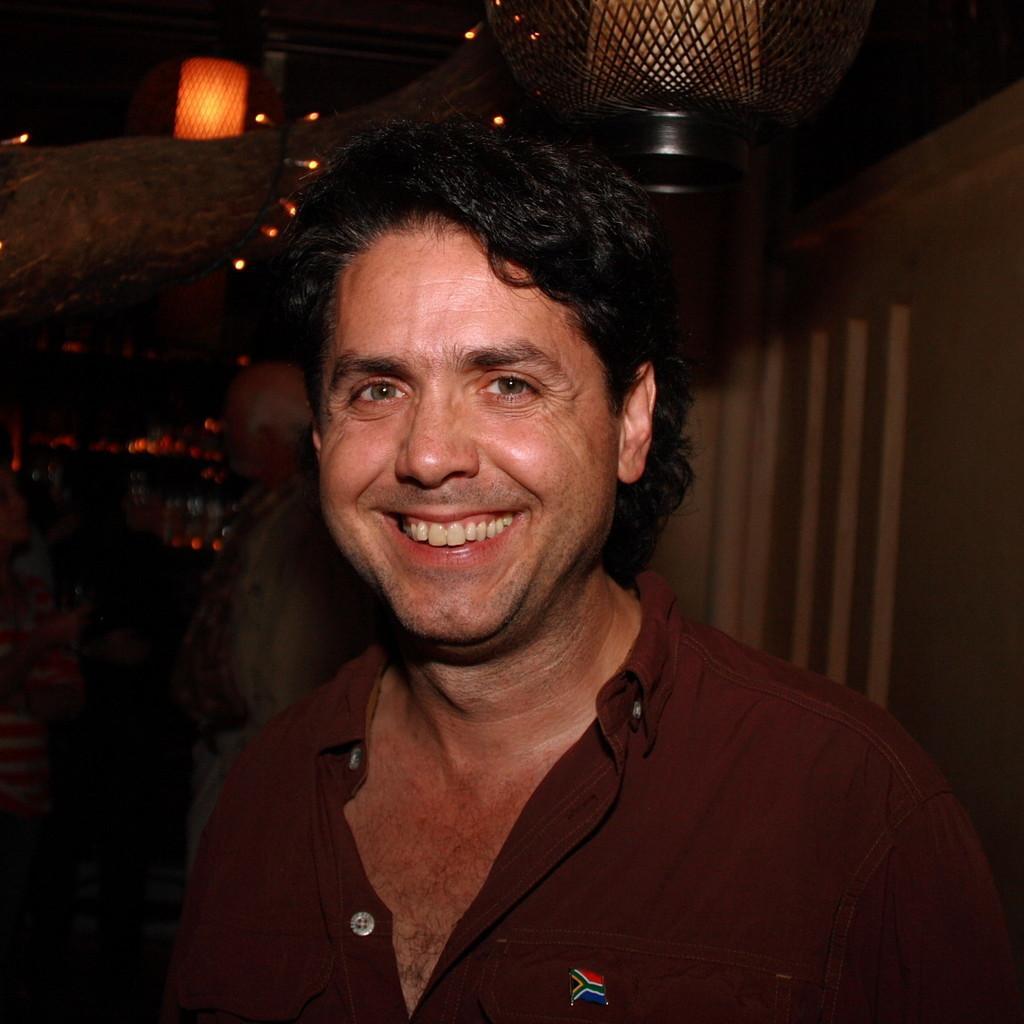In one or two sentences, can you explain what this image depicts? In this image there is a man standing. He is smiling. In the top left there is a branch of a tree. To the branch there are fairy lights hanging. There are lamps hanging to the ceiling. Behind the man there is another person standing. To the right there is a wall. The background is dark. 